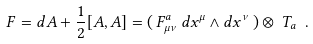Convert formula to latex. <formula><loc_0><loc_0><loc_500><loc_500>F = d A + \frac { 1 } { 2 } [ A , A ] = ( \, F ^ { a } _ { \mu \nu } \, d x ^ { \mu } \wedge d x ^ { \nu } \, ) \otimes \, T _ { a } \ .</formula> 